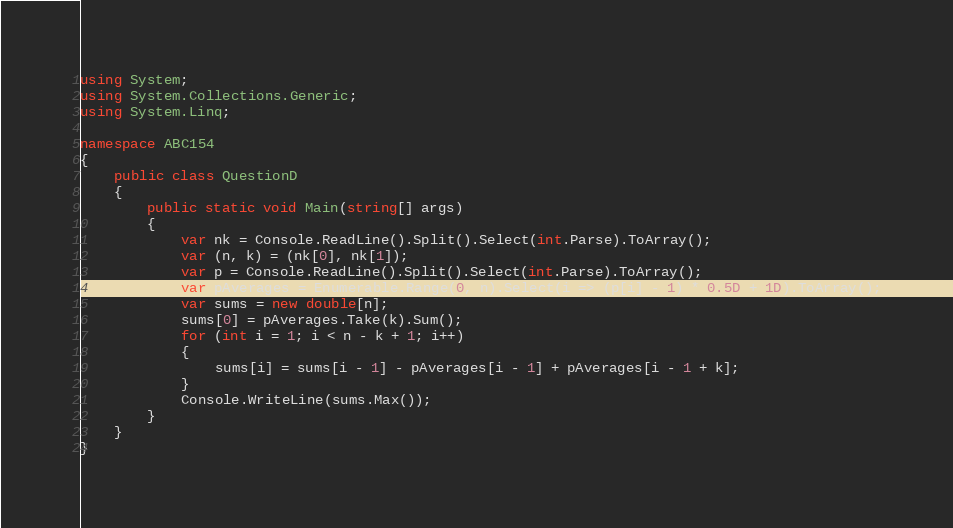Convert code to text. <code><loc_0><loc_0><loc_500><loc_500><_C#_>using System;
using System.Collections.Generic;
using System.Linq;

namespace ABC154
{
    public class QuestionD
    {
        public static void Main(string[] args)
        {
            var nk = Console.ReadLine().Split().Select(int.Parse).ToArray();
            var (n, k) = (nk[0], nk[1]);
            var p = Console.ReadLine().Split().Select(int.Parse).ToArray();
            var pAverages = Enumerable.Range(0, n).Select(i => (p[i] - 1) * 0.5D + 1D).ToArray();
            var sums = new double[n];
            sums[0] = pAverages.Take(k).Sum();
            for (int i = 1; i < n - k + 1; i++)
            {
                sums[i] = sums[i - 1] - pAverages[i - 1] + pAverages[i - 1 + k];
            }
            Console.WriteLine(sums.Max());
        }
    }
}

</code> 